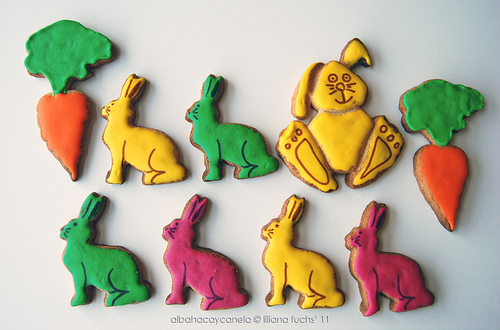<image>
Is there a rabbit to the right of the rabbit? Yes. From this viewpoint, the rabbit is positioned to the right side relative to the rabbit. 